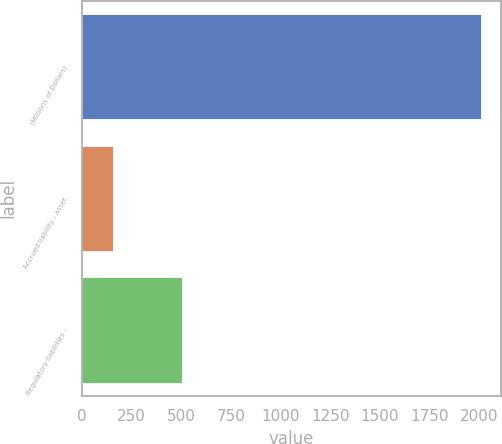<chart> <loc_0><loc_0><loc_500><loc_500><bar_chart><fcel>(Millions of Dollars)<fcel>Accrued liability - asset<fcel>Regulatory liabilities -<nl><fcel>2012<fcel>159<fcel>503<nl></chart> 